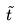<formula> <loc_0><loc_0><loc_500><loc_500>\tilde { t }</formula> 